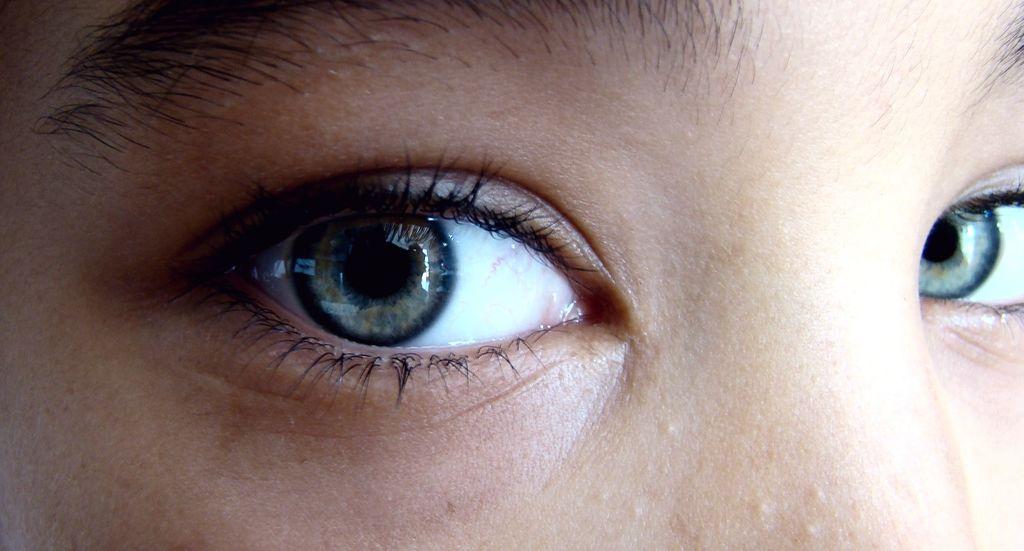How would you summarize this image in a sentence or two? In this image, we can see a human eyes, eyelashes, eyebrows and skin. 